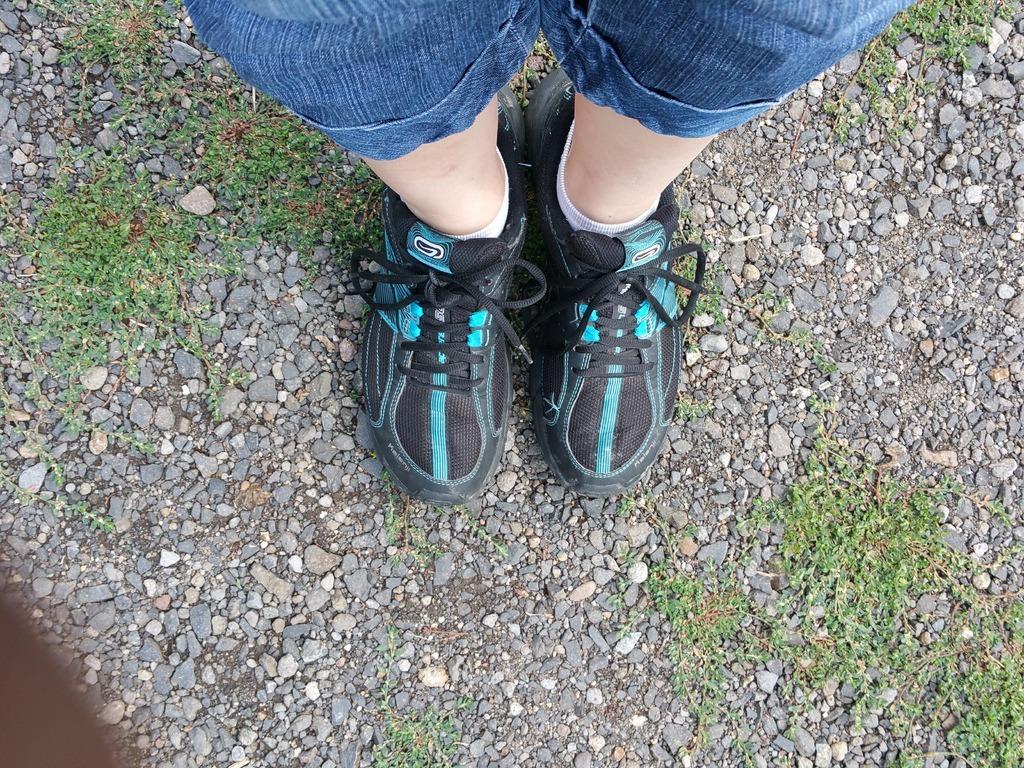Could you give a brief overview of what you see in this image? In the foreground of this image, on the top, there are two legs of a person's wearing shoes is standing on the land. Around legs, there is grass and few stones. 